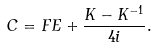<formula> <loc_0><loc_0><loc_500><loc_500>C = F E + \frac { K - K ^ { - 1 } } { 4 i } .</formula> 